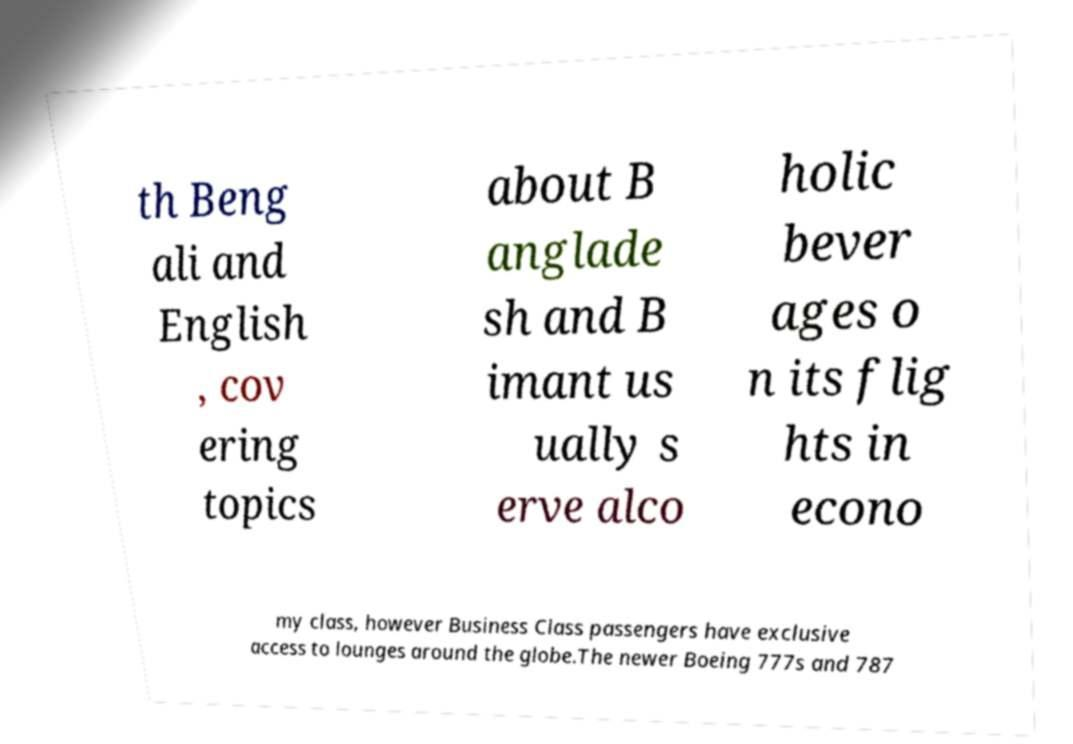Can you accurately transcribe the text from the provided image for me? th Beng ali and English , cov ering topics about B anglade sh and B imant us ually s erve alco holic bever ages o n its flig hts in econo my class, however Business Class passengers have exclusive access to lounges around the globe.The newer Boeing 777s and 787 